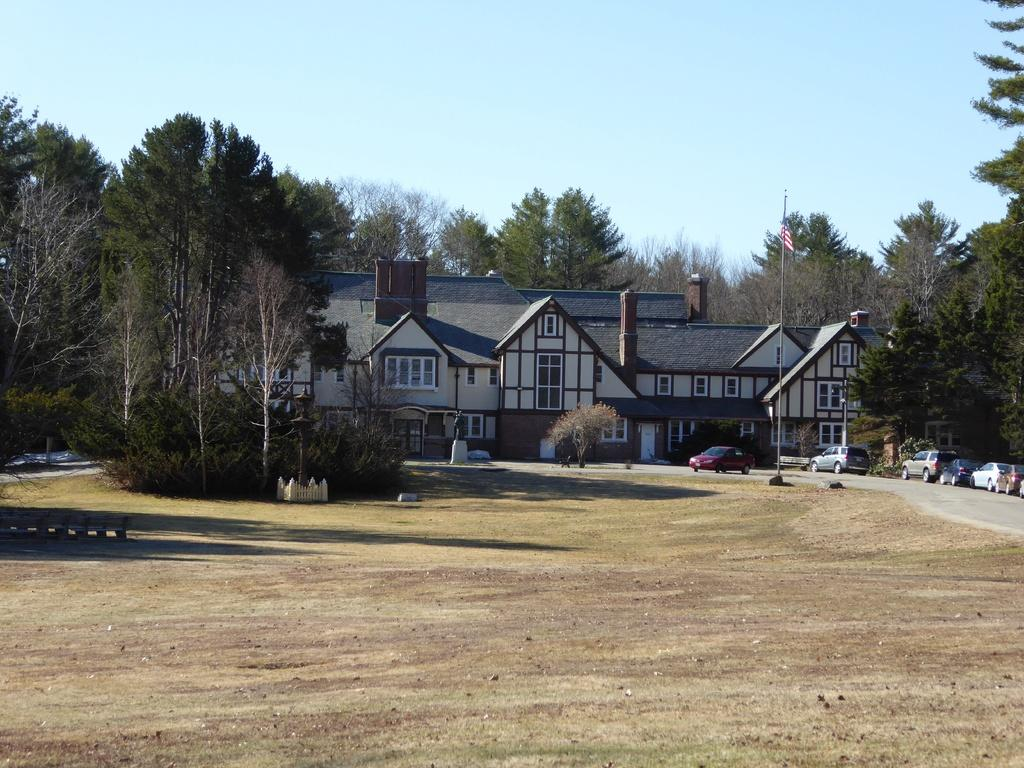What is the main subject in the center of the image? There is a building in the center of the image. What type of natural elements can be seen in the image? There are trees visible in the image. What type of transportation is present on the right side of the image? There are cars on the road on the right side of the image. What is visible in the background of the image? The sky is visible in the background of the image. What symbol or emblem can be seen in the image? There is a flag in the image. What is the profit margin of the building in the image? The image does not provide information about the profit margin of the building, as it is not related to the visual elements depicted. 